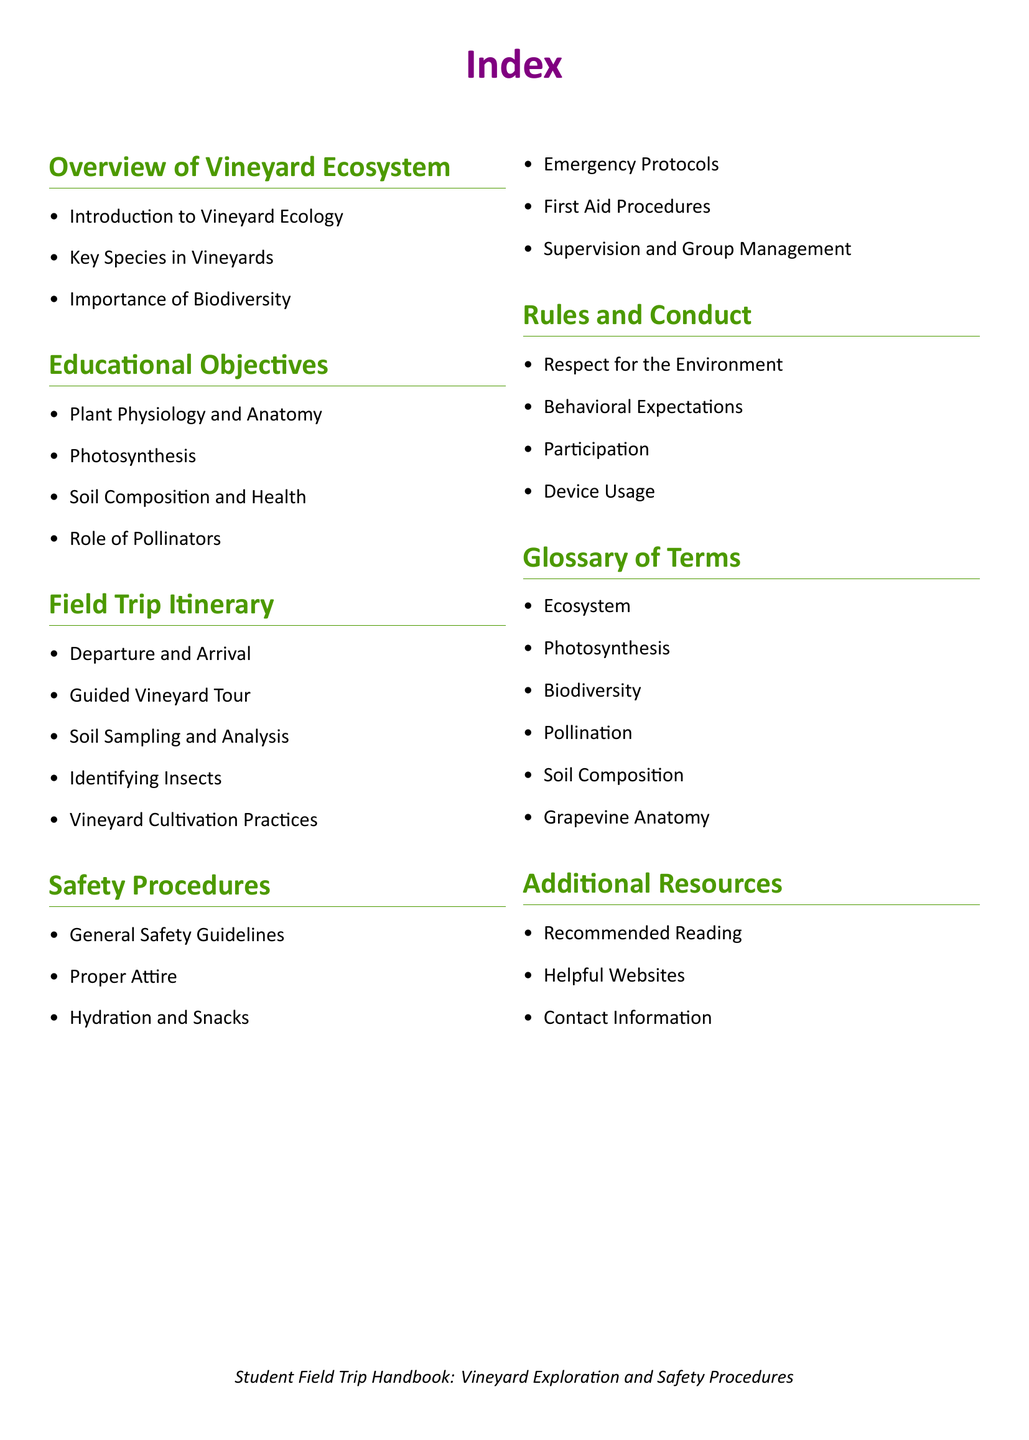what is the first topic in the Overview of Vineyard Ecosystem? The first topic listed is "Introduction to Vineyard Ecology."
Answer: Introduction to Vineyard Ecology how many key species are mentioned in the Overview of Vineyard Ecosystem? The document indicates that there is a section for "Key Species in Vineyards," implying at least one is mentioned.
Answer: At least one what is the second educational objective listed? The second educational objective after "Plant Physiology and Anatomy" is "Photosynthesis."
Answer: Photosynthesis which two activities are part of the Field Trip Itinerary? The itinerary includes activities such as "Soil Sampling and Analysis" and "Identifying Insects."
Answer: Soil Sampling and Analysis, Identifying Insects what is the first point listed under Safety Procedures? The first point listed is "General Safety Guidelines."
Answer: General Safety Guidelines how many terms are included in the Glossary of Terms? The glossary includes six terms that are listed.
Answer: Six what is expected from students regarding their behavior? Students are expected to adhere to the "Behavioral Expectations."
Answer: Behavioral Expectations what type of information is included in Additional Resources? The section includes "Recommended Reading" and "Helpful Websites."
Answer: Recommended Reading, Helpful Websites 